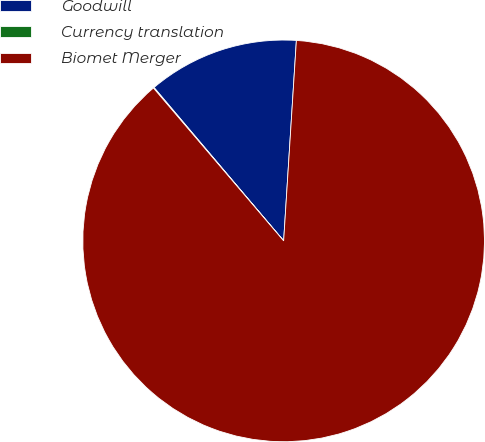<chart> <loc_0><loc_0><loc_500><loc_500><pie_chart><fcel>Goodwill<fcel>Currency translation<fcel>Biomet Merger<nl><fcel>12.18%<fcel>0.06%<fcel>87.76%<nl></chart> 